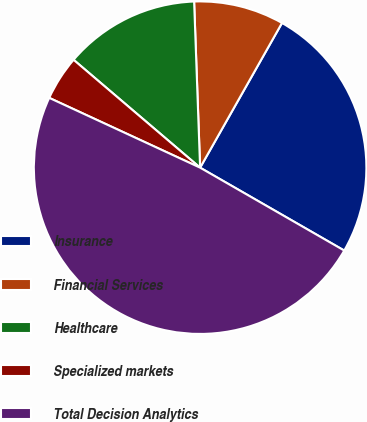Convert chart to OTSL. <chart><loc_0><loc_0><loc_500><loc_500><pie_chart><fcel>Insurance<fcel>Financial Services<fcel>Healthcare<fcel>Specialized markets<fcel>Total Decision Analytics<nl><fcel>25.11%<fcel>8.77%<fcel>13.19%<fcel>4.34%<fcel>48.59%<nl></chart> 